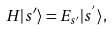Convert formula to latex. <formula><loc_0><loc_0><loc_500><loc_500>H | s ^ { \prime } \rangle = E _ { s ^ { \prime } } | s ^ { ^ { \prime } } \rangle ,</formula> 